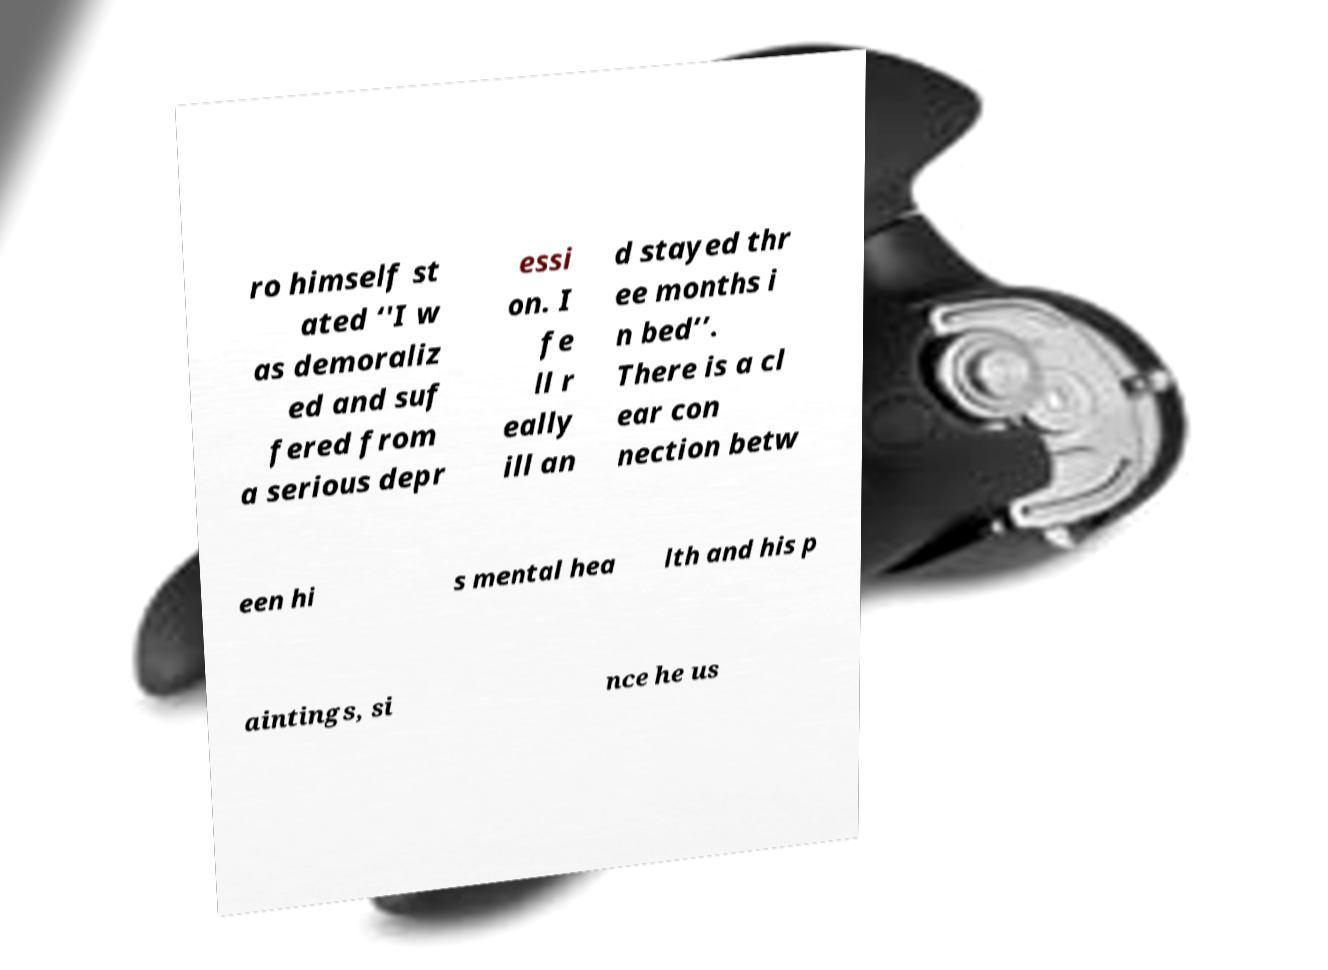Please identify and transcribe the text found in this image. ro himself st ated ‘'I w as demoraliz ed and suf fered from a serious depr essi on. I fe ll r eally ill an d stayed thr ee months i n bed’’. There is a cl ear con nection betw een hi s mental hea lth and his p aintings, si nce he us 